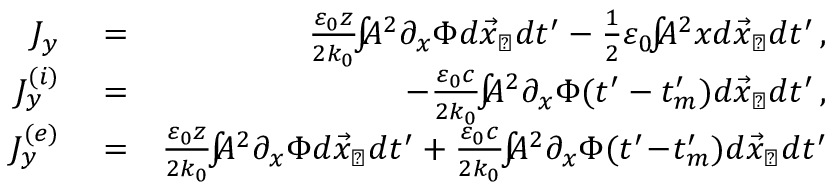<formula> <loc_0><loc_0><loc_500><loc_500>\begin{array} { r l r } { J _ { y } } & = } & { \frac { \varepsilon _ { 0 } z } { 2 k _ { 0 } } \, \int \, A ^ { 2 } \partial _ { x } \Phi d \vec { x } _ { \perp } d t ^ { \prime } - \frac { 1 } { 2 } \varepsilon _ { 0 } \, \int \, A ^ { 2 } x d \vec { x } _ { \perp } d t ^ { \prime } \, , } \\ { J _ { y } ^ { ( i ) } } & = } & { - \frac { \varepsilon _ { 0 } c } { 2 k _ { 0 } } \, \int \, A ^ { 2 } \partial _ { x } \Phi ( t ^ { \prime } - t _ { m } ^ { \prime } ) d \vec { x } _ { \perp } d t ^ { \prime } \, , } \\ { J _ { y } ^ { ( e ) } } & = } & { \frac { \varepsilon _ { 0 } z } { 2 k _ { 0 } } \, \int \, A ^ { 2 } \partial _ { x } \Phi d \vec { x } _ { \perp } d t ^ { \prime } + \frac { \varepsilon _ { 0 } c } { 2 k _ { 0 } } \, \int \, A ^ { 2 } \partial _ { x } \Phi ( t ^ { \prime } \, - \, t _ { m } ^ { \prime } ) d \vec { x } _ { \perp } d t ^ { \prime } } \end{array}</formula> 